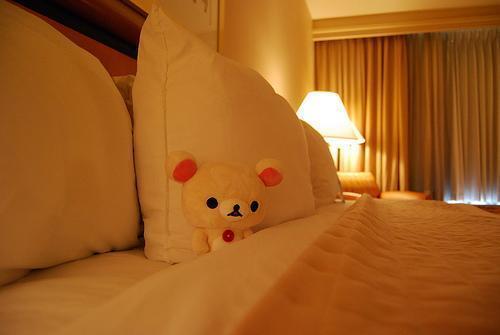How many beds are in the photo?
Give a very brief answer. 1. How many girls are there?
Give a very brief answer. 0. 